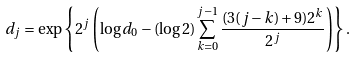<formula> <loc_0><loc_0><loc_500><loc_500>d _ { j } = \exp \left \{ 2 ^ { j } \left ( \log d _ { 0 } - ( \log 2 ) \sum _ { k = 0 } ^ { j - 1 } \frac { ( 3 ( j - k ) + 9 ) 2 ^ { k } } { 2 ^ { j } } \right ) \right \} .</formula> 